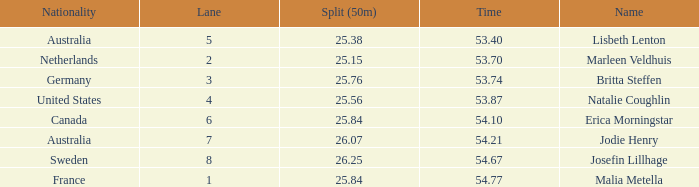What is the total of lane(s) for swimmers from Sweden with a 50m split of faster than 26.25? None. 